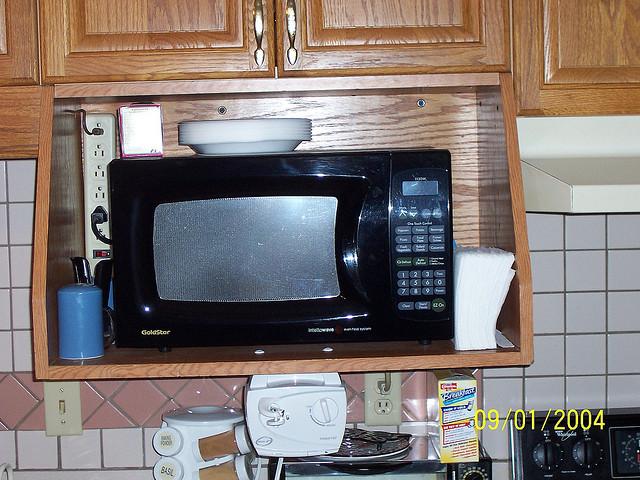When was this picture taken?
Keep it brief. 09/01/2004. What kind of wall is in the picture?
Concise answer only. Tile. Is this a bathroom?
Be succinct. No. 